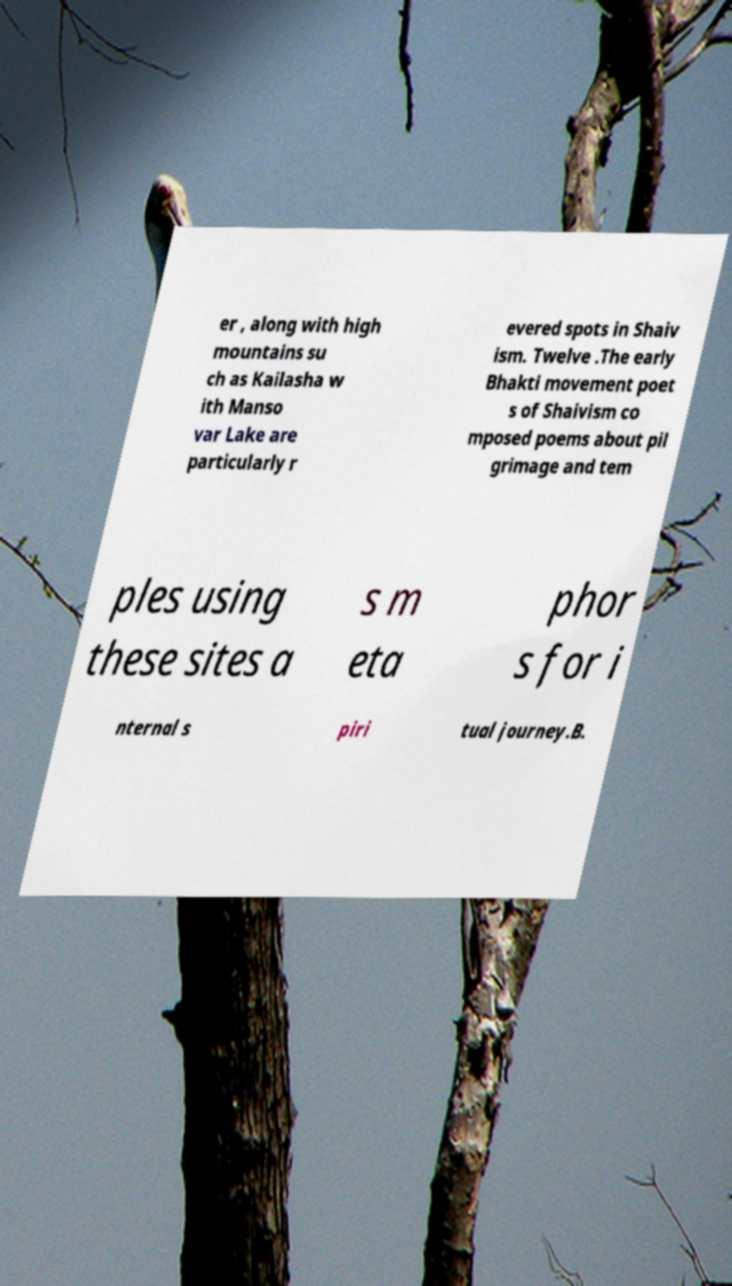For documentation purposes, I need the text within this image transcribed. Could you provide that? er , along with high mountains su ch as Kailasha w ith Manso var Lake are particularly r evered spots in Shaiv ism. Twelve .The early Bhakti movement poet s of Shaivism co mposed poems about pil grimage and tem ples using these sites a s m eta phor s for i nternal s piri tual journey.B. 